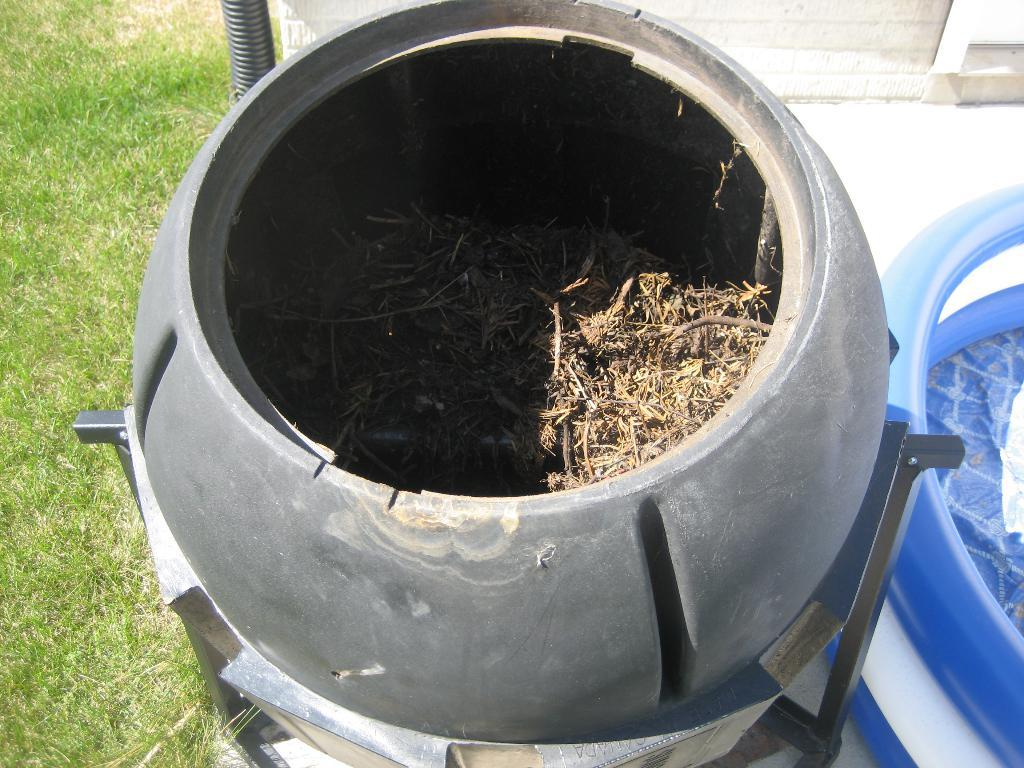What is the main object on the stand in the image? There is a black object on a stand in the image. What is covering the black object? The black object has grass on it. What other object can be seen in the image? There is a tube in the image. What colors are present on the tube? The tube has blue and white colors. How many girls are walking on the sidewalk in the image? There are no girls or sidewalks present in the image. 